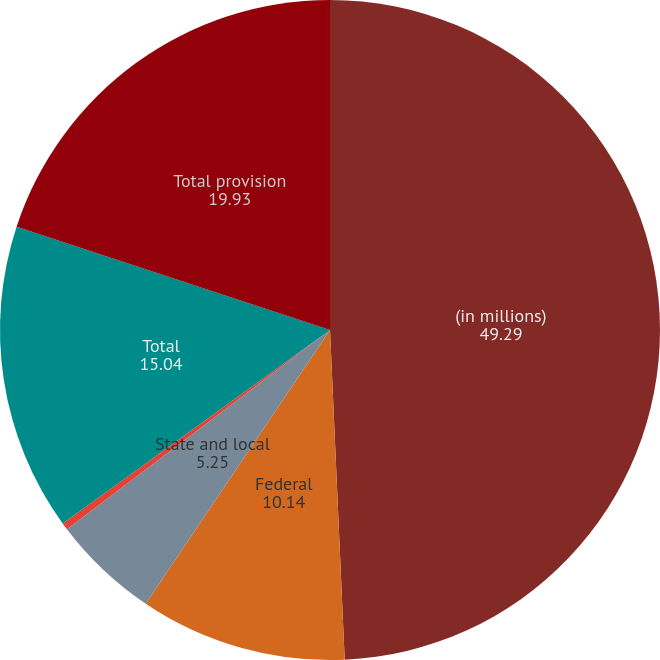Convert chart. <chart><loc_0><loc_0><loc_500><loc_500><pie_chart><fcel>(in millions)<fcel>Federal<fcel>State and local<fcel>Non-US<fcel>Total<fcel>Total provision<nl><fcel>49.29%<fcel>10.14%<fcel>5.25%<fcel>0.35%<fcel>15.04%<fcel>19.93%<nl></chart> 